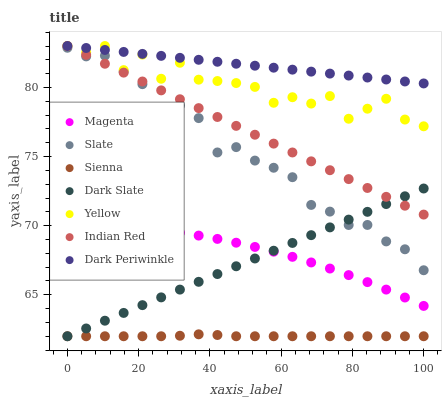Does Sienna have the minimum area under the curve?
Answer yes or no. Yes. Does Dark Periwinkle have the maximum area under the curve?
Answer yes or no. Yes. Does Yellow have the minimum area under the curve?
Answer yes or no. No. Does Yellow have the maximum area under the curve?
Answer yes or no. No. Is Indian Red the smoothest?
Answer yes or no. Yes. Is Yellow the roughest?
Answer yes or no. Yes. Is Sienna the smoothest?
Answer yes or no. No. Is Sienna the roughest?
Answer yes or no. No. Does Sienna have the lowest value?
Answer yes or no. Yes. Does Yellow have the lowest value?
Answer yes or no. No. Does Dark Periwinkle have the highest value?
Answer yes or no. Yes. Does Sienna have the highest value?
Answer yes or no. No. Is Dark Slate less than Yellow?
Answer yes or no. Yes. Is Yellow greater than Dark Slate?
Answer yes or no. Yes. Does Slate intersect Dark Slate?
Answer yes or no. Yes. Is Slate less than Dark Slate?
Answer yes or no. No. Is Slate greater than Dark Slate?
Answer yes or no. No. Does Dark Slate intersect Yellow?
Answer yes or no. No. 